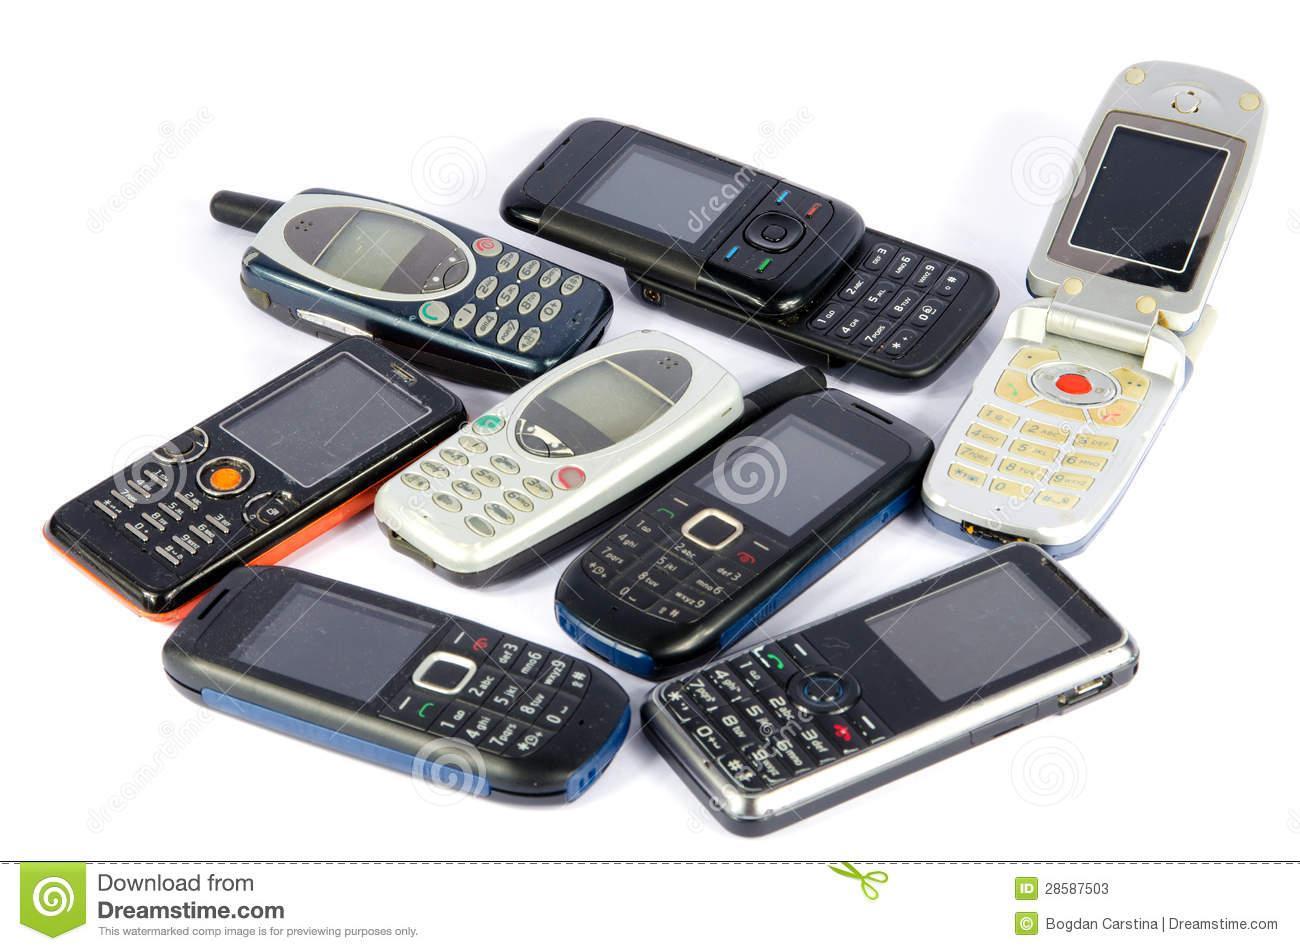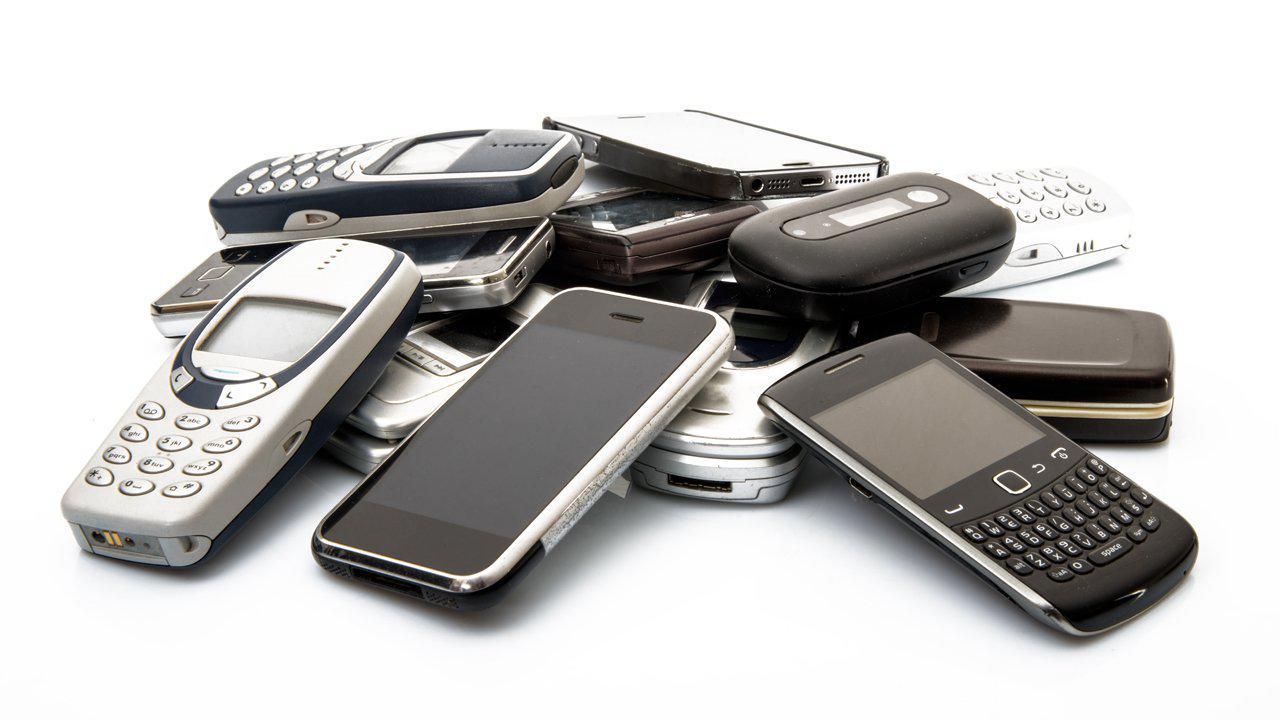The first image is the image on the left, the second image is the image on the right. Considering the images on both sides, is "The left image contains no more than two phones, and the right image shows a messy pile of at least a dozen phones." valid? Answer yes or no. No. 